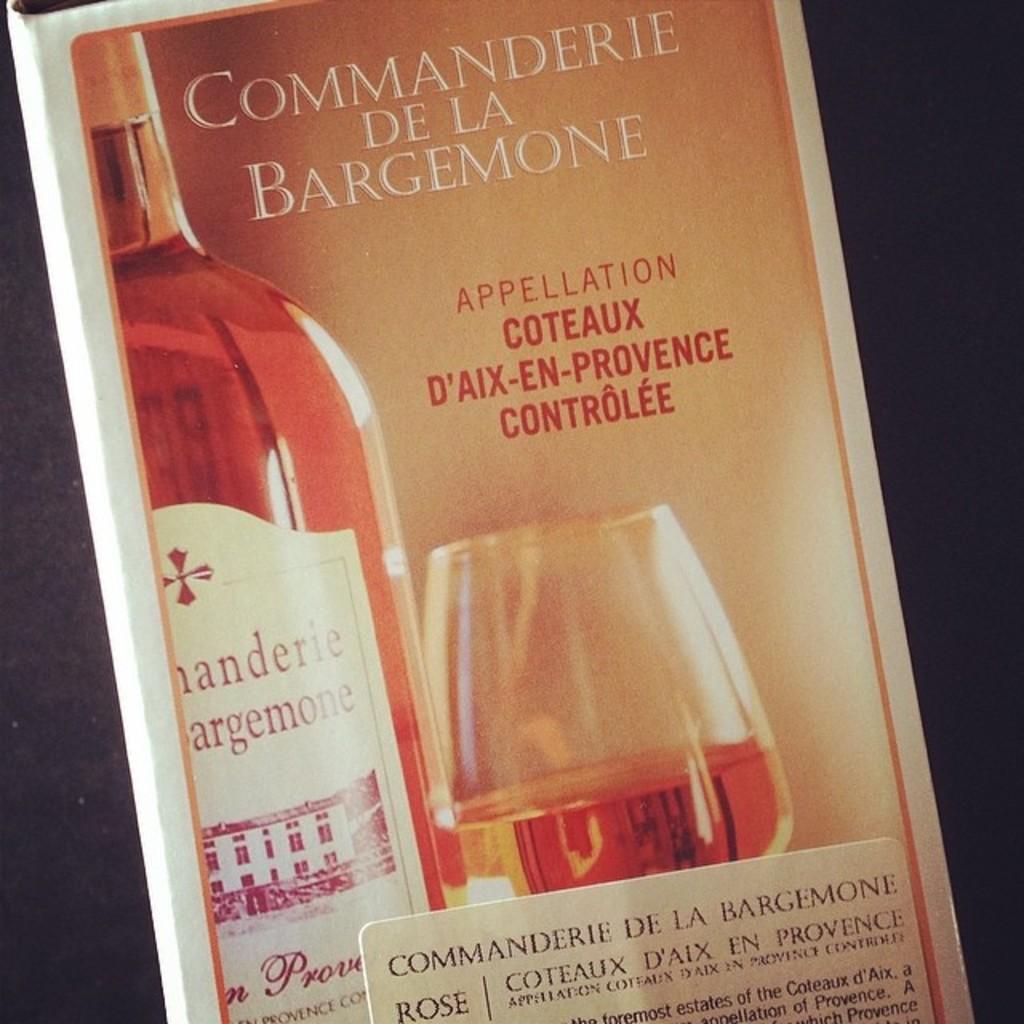Who makes the spirit?
Provide a succinct answer. Commanderie de la bargemone. 